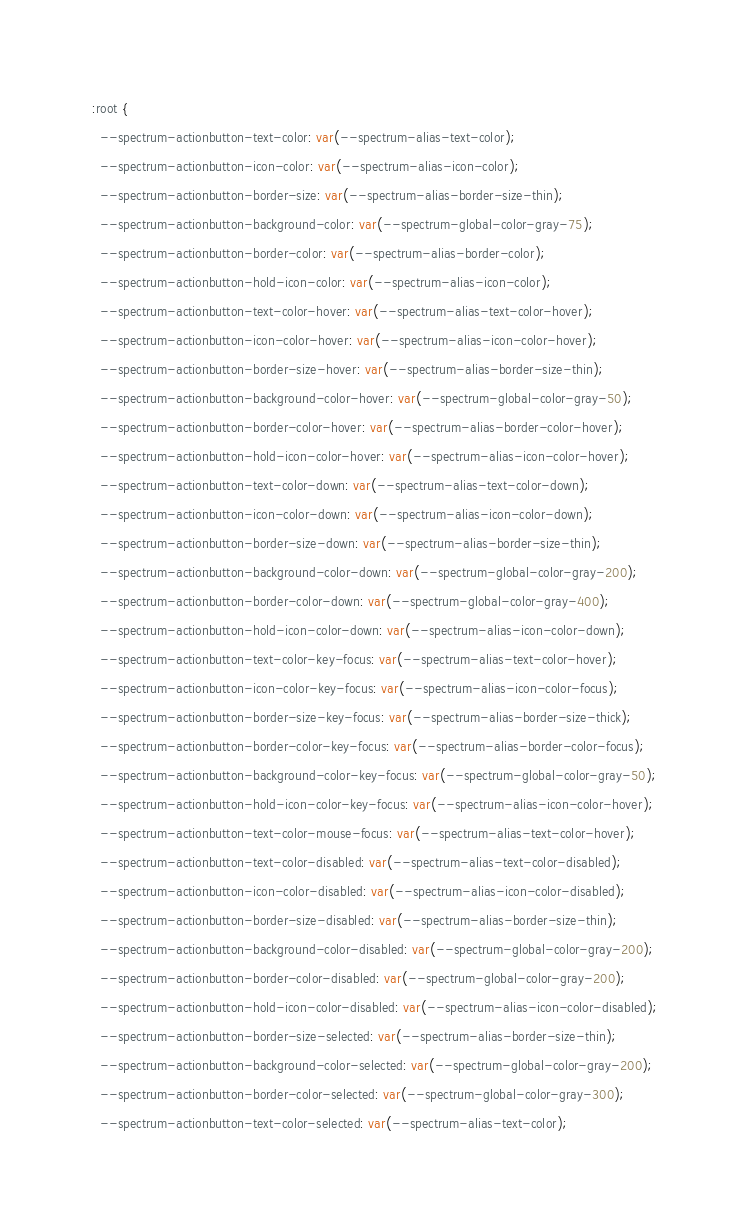<code> <loc_0><loc_0><loc_500><loc_500><_CSS_>:root {
  --spectrum-actionbutton-text-color: var(--spectrum-alias-text-color);
  --spectrum-actionbutton-icon-color: var(--spectrum-alias-icon-color);
  --spectrum-actionbutton-border-size: var(--spectrum-alias-border-size-thin);
  --spectrum-actionbutton-background-color: var(--spectrum-global-color-gray-75);
  --spectrum-actionbutton-border-color: var(--spectrum-alias-border-color);
  --spectrum-actionbutton-hold-icon-color: var(--spectrum-alias-icon-color);
  --spectrum-actionbutton-text-color-hover: var(--spectrum-alias-text-color-hover);
  --spectrum-actionbutton-icon-color-hover: var(--spectrum-alias-icon-color-hover);
  --spectrum-actionbutton-border-size-hover: var(--spectrum-alias-border-size-thin);
  --spectrum-actionbutton-background-color-hover: var(--spectrum-global-color-gray-50);
  --spectrum-actionbutton-border-color-hover: var(--spectrum-alias-border-color-hover);
  --spectrum-actionbutton-hold-icon-color-hover: var(--spectrum-alias-icon-color-hover);
  --spectrum-actionbutton-text-color-down: var(--spectrum-alias-text-color-down);
  --spectrum-actionbutton-icon-color-down: var(--spectrum-alias-icon-color-down);
  --spectrum-actionbutton-border-size-down: var(--spectrum-alias-border-size-thin);
  --spectrum-actionbutton-background-color-down: var(--spectrum-global-color-gray-200);
  --spectrum-actionbutton-border-color-down: var(--spectrum-global-color-gray-400);
  --spectrum-actionbutton-hold-icon-color-down: var(--spectrum-alias-icon-color-down);
  --spectrum-actionbutton-text-color-key-focus: var(--spectrum-alias-text-color-hover);
  --spectrum-actionbutton-icon-color-key-focus: var(--spectrum-alias-icon-color-focus);
  --spectrum-actionbutton-border-size-key-focus: var(--spectrum-alias-border-size-thick);
  --spectrum-actionbutton-border-color-key-focus: var(--spectrum-alias-border-color-focus);
  --spectrum-actionbutton-background-color-key-focus: var(--spectrum-global-color-gray-50);
  --spectrum-actionbutton-hold-icon-color-key-focus: var(--spectrum-alias-icon-color-hover);
  --spectrum-actionbutton-text-color-mouse-focus: var(--spectrum-alias-text-color-hover);
  --spectrum-actionbutton-text-color-disabled: var(--spectrum-alias-text-color-disabled);
  --spectrum-actionbutton-icon-color-disabled: var(--spectrum-alias-icon-color-disabled);
  --spectrum-actionbutton-border-size-disabled: var(--spectrum-alias-border-size-thin);
  --spectrum-actionbutton-background-color-disabled: var(--spectrum-global-color-gray-200);
  --spectrum-actionbutton-border-color-disabled: var(--spectrum-global-color-gray-200);
  --spectrum-actionbutton-hold-icon-color-disabled: var(--spectrum-alias-icon-color-disabled);
  --spectrum-actionbutton-border-size-selected: var(--spectrum-alias-border-size-thin);
  --spectrum-actionbutton-background-color-selected: var(--spectrum-global-color-gray-200);
  --spectrum-actionbutton-border-color-selected: var(--spectrum-global-color-gray-300);
  --spectrum-actionbutton-text-color-selected: var(--spectrum-alias-text-color);</code> 